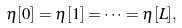Convert formula to latex. <formula><loc_0><loc_0><loc_500><loc_500>\eta [ 0 ] = \eta [ 1 ] = \cdots = \eta [ L ] ,</formula> 